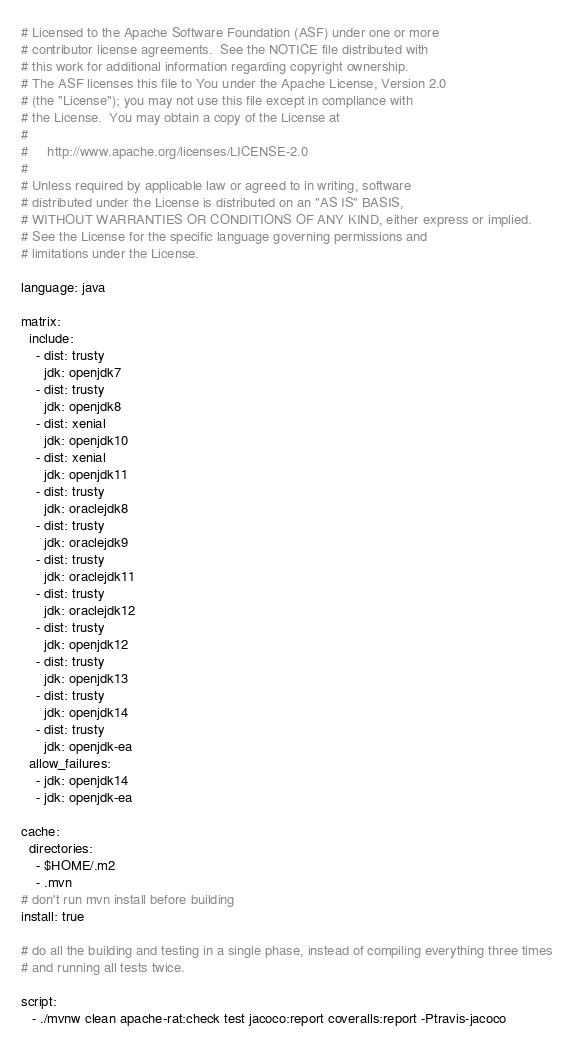Convert code to text. <code><loc_0><loc_0><loc_500><loc_500><_YAML_># Licensed to the Apache Software Foundation (ASF) under one or more
# contributor license agreements.  See the NOTICE file distributed with
# this work for additional information regarding copyright ownership.
# The ASF licenses this file to You under the Apache License, Version 2.0
# (the "License"); you may not use this file except in compliance with
# the License.  You may obtain a copy of the License at
#
#     http://www.apache.org/licenses/LICENSE-2.0
#
# Unless required by applicable law or agreed to in writing, software
# distributed under the License is distributed on an "AS IS" BASIS,
# WITHOUT WARRANTIES OR CONDITIONS OF ANY KIND, either express or implied.
# See the License for the specific language governing permissions and
# limitations under the License.

language: java

matrix:
  include:
    - dist: trusty
      jdk: openjdk7
    - dist: trusty
      jdk: openjdk8
    - dist: xenial
      jdk: openjdk10
    - dist: xenial
      jdk: openjdk11
    - dist: trusty
      jdk: oraclejdk8
    - dist: trusty
      jdk: oraclejdk9
    - dist: trusty
      jdk: oraclejdk11
    - dist: trusty
      jdk: oraclejdk12
    - dist: trusty
      jdk: openjdk12
    - dist: trusty
      jdk: openjdk13
    - dist: trusty
      jdk: openjdk14
    - dist: trusty
      jdk: openjdk-ea
  allow_failures:
    - jdk: openjdk14
    - jdk: openjdk-ea

cache:
  directories:
    - $HOME/.m2
    - .mvn
# don't run mvn install before building
install: true

# do all the building and testing in a single phase, instead of compiling everything three times
# and running all tests twice.

script:
   - ./mvnw clean apache-rat:check test jacoco:report coveralls:report -Ptravis-jacoco
</code> 